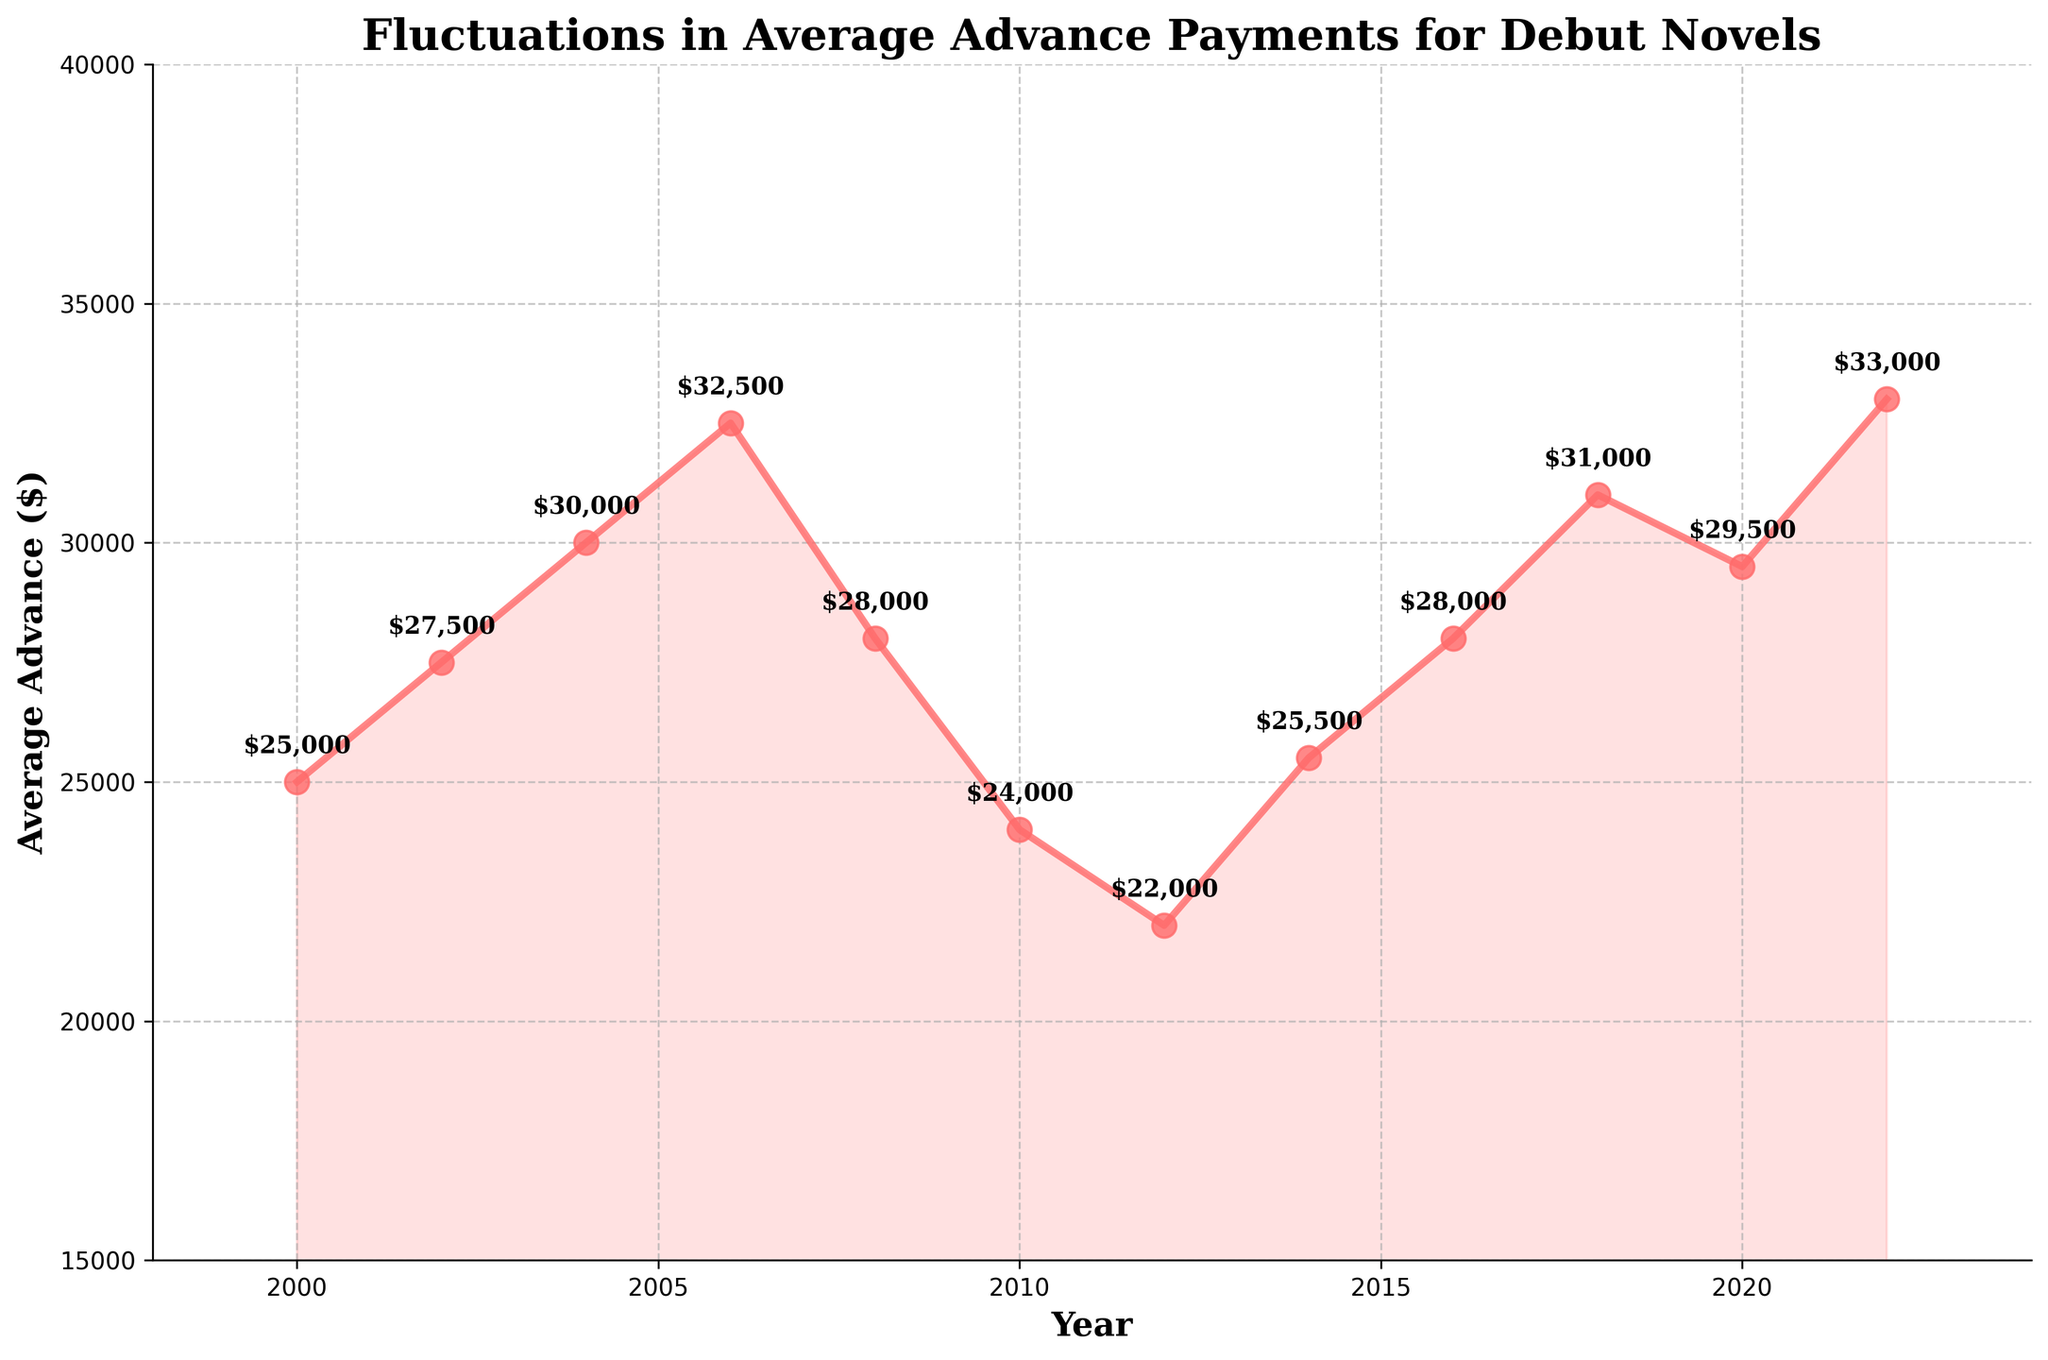When did the average advance payments for debut novels experience its lowest point, and what was the amount? The lowest point can be identified by looking for the minimum y-value (average advance amount) on the y-axis. According to the graph, this occurs in the year 2012 at $22,000.
Answer: 2012, $22,000 Between which years did the average advance payments see the steepest decline? The steepest decline can be identified by finding the segment with the most significant negative slope. The steepest decline is between 2006 and 2012, going from $32,500 down to $22,000.
Answer: 2006-2012 How much did the average advance payments increase from 2018 to 2022? By looking at the values for the years 2018 and 2022, the difference is calculated as $33,000 (2022) - $31,000 (2018) = $2,000.
Answer: $2,000 What is the average annual advance payment for debut novels over the period 2000 to 2022? To calculate the average, sum all the advance payments and then divide by the number of years. Sum: $25,000 + $27,500 + $30,000 + $32,500 + $28,000 + $24,000 + $22,000 + $25,500 + $28,000 + $31,000 + $29,500 + $33,000 = $336,000. Number of data points: 12. Average = $336,000 / 12 ≈ $28,000.
Answer: $28,000 Was there a year when the average advance payment was the same as in 2000? If so, which year? By looking at the graph and the values, there is no other year that matches the $25,000 advance payment in 2000 exactly.
Answer: No How does the average advance payment in 2020 compare to that of 2010? Comparing the values directly: 2020 ($29,500) is greater than 2010 ($24,000).
Answer: 2020 is greater than 2010 Which year shows the greatest positive change in average advance payment compared to the previous year? The greatest positive change can be identified by the steepest rise. By comparing consecutive years, the largest increase is from 2000 to 2002, with an increase of $2,500.
Answer: 2000 to 2002 What is the total increase in average advance payments from 2000 to 2022? Calculate the difference between the amounts in 2022 ($33,000) and 2000 ($25,000): $33,000 - $25,000 = $8,000.
Answer: $8,000 What color is the line chart that represents average advance payments? The line chart is visually discerned as red.
Answer: Red What's the median value of the average advance payments over the period 2000 to 2022? Arrange the values in ascending order and then find the middle value. Values: [$22,000, $24,000, $25,000, $25,500, $27,500, $28,000, $28,000, $29,500, $30,000, $31,000, $32,500, $33,000]. Median is the average of 6th and 7th values ($28,000 + $28,000) / 2 = $28,000.
Answer: $28,000 